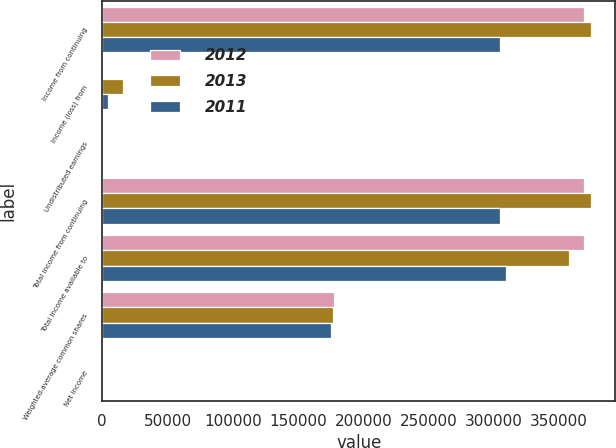<chart> <loc_0><loc_0><loc_500><loc_500><stacked_bar_chart><ecel><fcel>Income from continuing<fcel>Income (loss) from<fcel>Undistributed earnings<fcel>Total income from continuing<fcel>Total income available to<fcel>Weighted-average common shares<fcel>Net income<nl><fcel>2012<fcel>369264<fcel>0<fcel>84<fcel>369120<fcel>369120<fcel>177814<fcel>2.08<nl><fcel>2013<fcel>374250<fcel>16180<fcel>58<fcel>374106<fcel>357926<fcel>176445<fcel>2.03<nl><fcel>2011<fcel>304929<fcel>4684<fcel>65<fcel>304796<fcel>309480<fcel>175484<fcel>1.76<nl></chart> 